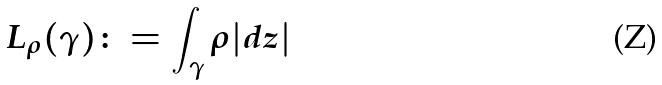<formula> <loc_0><loc_0><loc_500><loc_500>L _ { \rho } ( \gamma ) \colon = \int _ { \gamma } \rho | d z |</formula> 